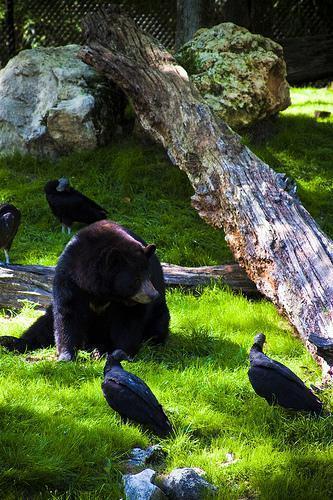How many birds are in front of the bear?
Give a very brief answer. 2. 